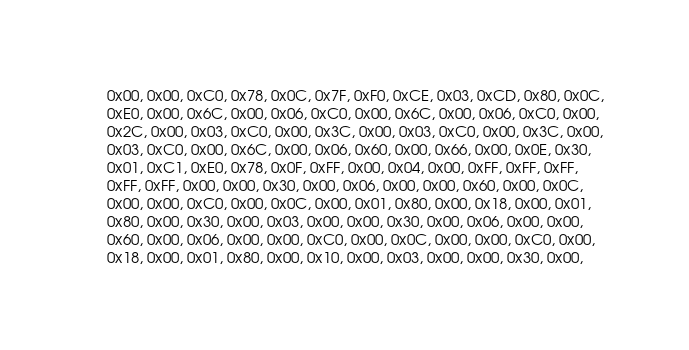<code> <loc_0><loc_0><loc_500><loc_500><_C_>  0x00, 0x00, 0xC0, 0x78, 0x0C, 0x7F, 0xF0, 0xCE, 0x03, 0xCD, 0x80, 0x0C,
  0xE0, 0x00, 0x6C, 0x00, 0x06, 0xC0, 0x00, 0x6C, 0x00, 0x06, 0xC0, 0x00,
  0x2C, 0x00, 0x03, 0xC0, 0x00, 0x3C, 0x00, 0x03, 0xC0, 0x00, 0x3C, 0x00,
  0x03, 0xC0, 0x00, 0x6C, 0x00, 0x06, 0x60, 0x00, 0x66, 0x00, 0x0E, 0x30,
  0x01, 0xC1, 0xE0, 0x78, 0x0F, 0xFF, 0x00, 0x04, 0x00, 0xFF, 0xFF, 0xFF,
  0xFF, 0xFF, 0x00, 0x00, 0x30, 0x00, 0x06, 0x00, 0x00, 0x60, 0x00, 0x0C,
  0x00, 0x00, 0xC0, 0x00, 0x0C, 0x00, 0x01, 0x80, 0x00, 0x18, 0x00, 0x01,
  0x80, 0x00, 0x30, 0x00, 0x03, 0x00, 0x00, 0x30, 0x00, 0x06, 0x00, 0x00,
  0x60, 0x00, 0x06, 0x00, 0x00, 0xC0, 0x00, 0x0C, 0x00, 0x00, 0xC0, 0x00,
  0x18, 0x00, 0x01, 0x80, 0x00, 0x10, 0x00, 0x03, 0x00, 0x00, 0x30, 0x00,</code> 